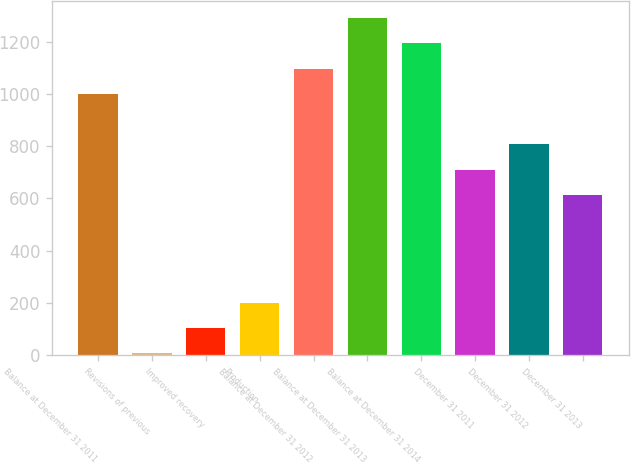Convert chart. <chart><loc_0><loc_0><loc_500><loc_500><bar_chart><fcel>Balance at December 31 2011<fcel>Revisions of previous<fcel>Improved recovery<fcel>Production<fcel>Balance at December 31 2012<fcel>Balance at December 31 2013<fcel>Balance at December 31 2014<fcel>December 31 2011<fcel>December 31 2012<fcel>December 31 2013<nl><fcel>1000.6<fcel>7<fcel>103.9<fcel>200.8<fcel>1097.5<fcel>1291.3<fcel>1194.4<fcel>709.9<fcel>806.8<fcel>613<nl></chart> 